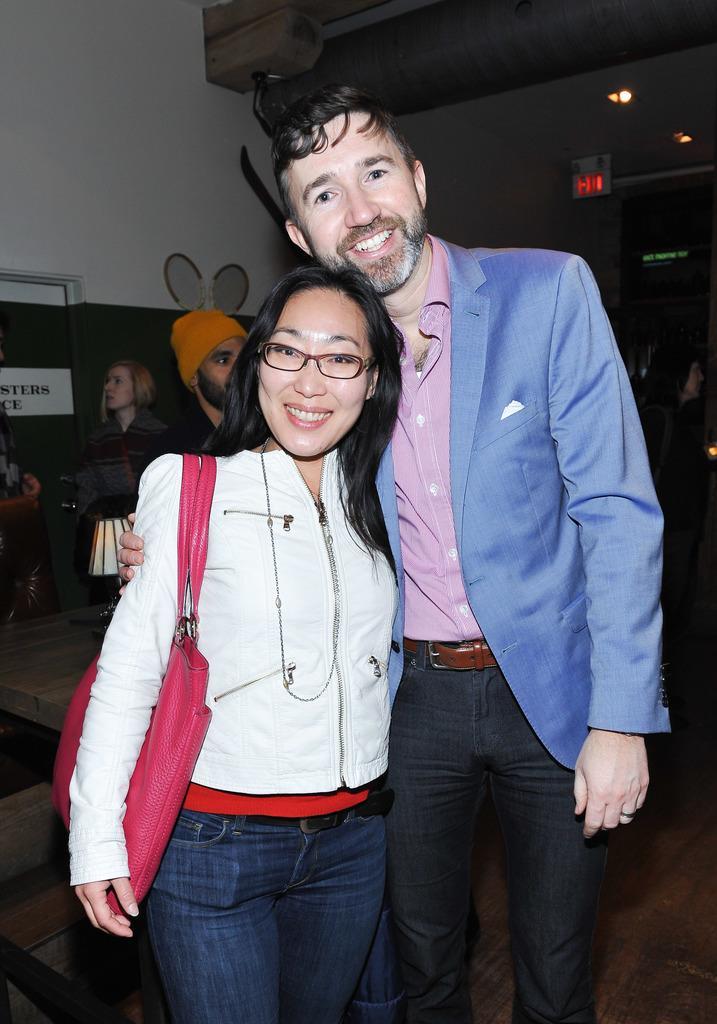Describe this image in one or two sentences. In this picture we can observe a couple. We can observe a man and a woman. The woman is wearing white color jacket and spectacles. The man is wearing a blue color coat. Both of them are smiling. In the background there are some people and we can observe a wall. 